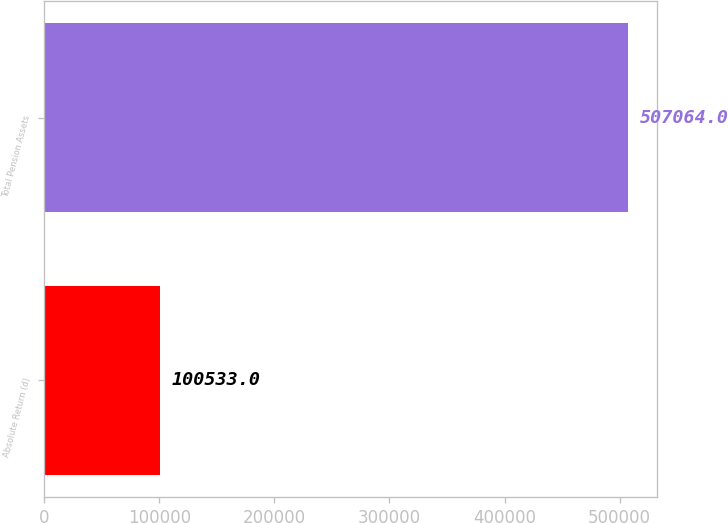Convert chart to OTSL. <chart><loc_0><loc_0><loc_500><loc_500><bar_chart><fcel>Absolute Return (d)<fcel>Total Pension Assets<nl><fcel>100533<fcel>507064<nl></chart> 